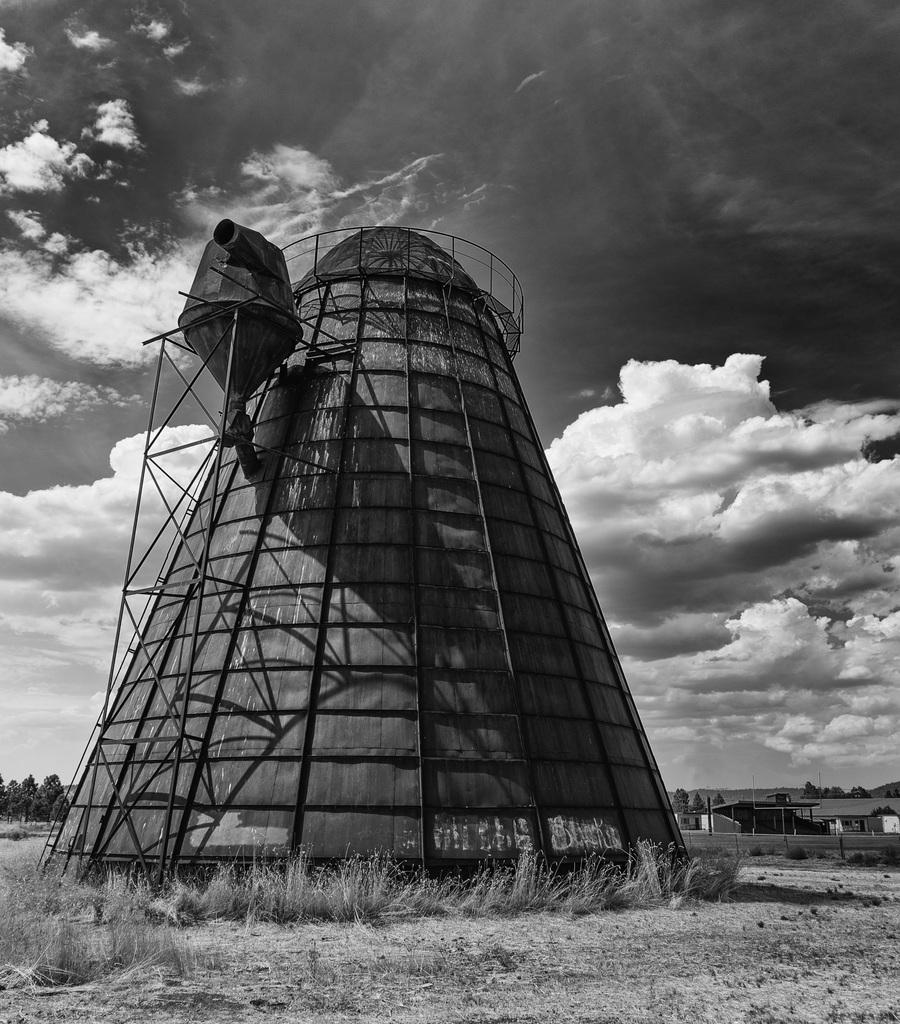What type of vegetation can be seen in the image? There is grass in the image. What is the color scheme of the image? The image is monochrome (black and white). What can be seen in the background of the image? There are trees on the backside of the image. What structure is located on the right side of the image? There is a shed on the right side of the image. What is visible in the sky in the image? There are clouds in the sky in the image. What type of prose is being recited by the tree in the image? There is no prose or recitation in the image; it features grass, trees, a shed, and clouds. What is the cork used for in the image? There is no cork present in the image. 